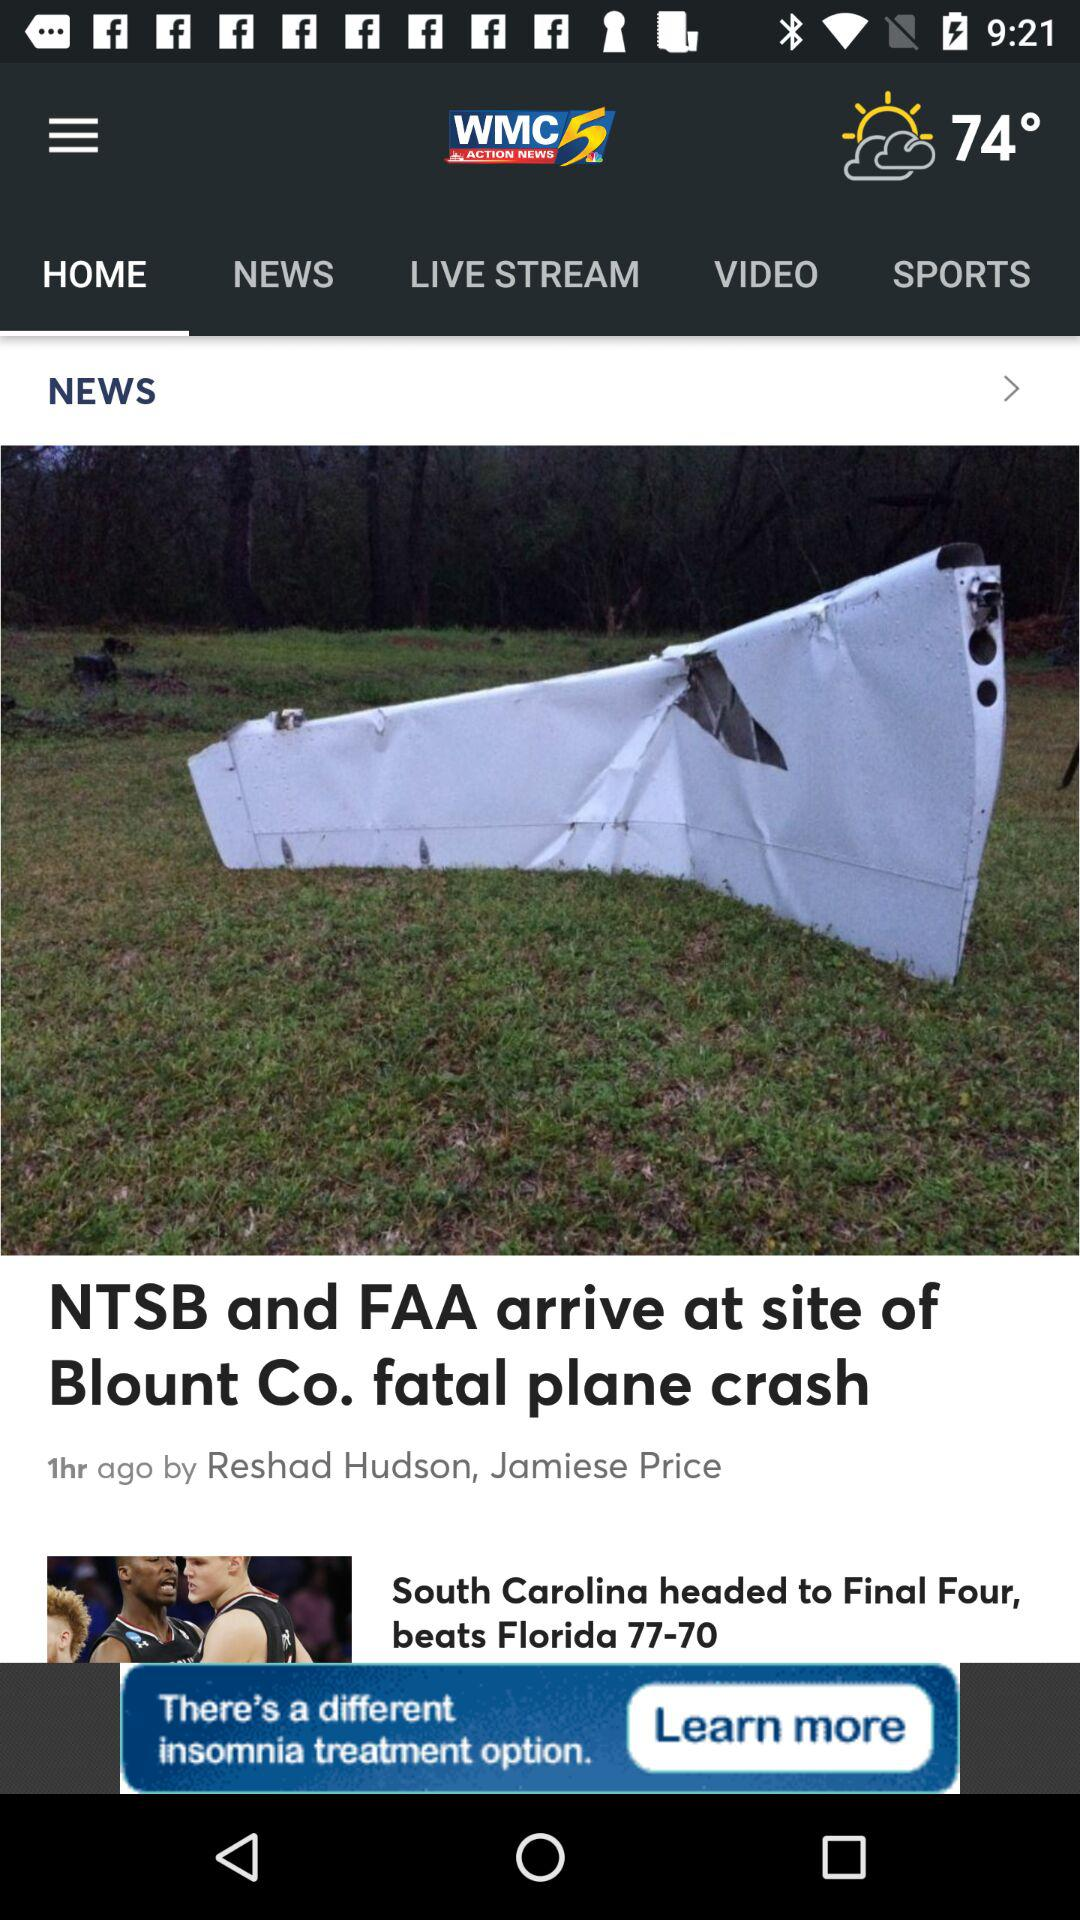What is the temperature? The temperature is 74°. 